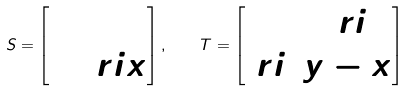<formula> <loc_0><loc_0><loc_500><loc_500>S = \begin{bmatrix} 0 & 1 \\ 1 & \ r i x \end{bmatrix} , \quad T = \begin{bmatrix} 0 & \ r i \\ \ r i & y - x \end{bmatrix}</formula> 